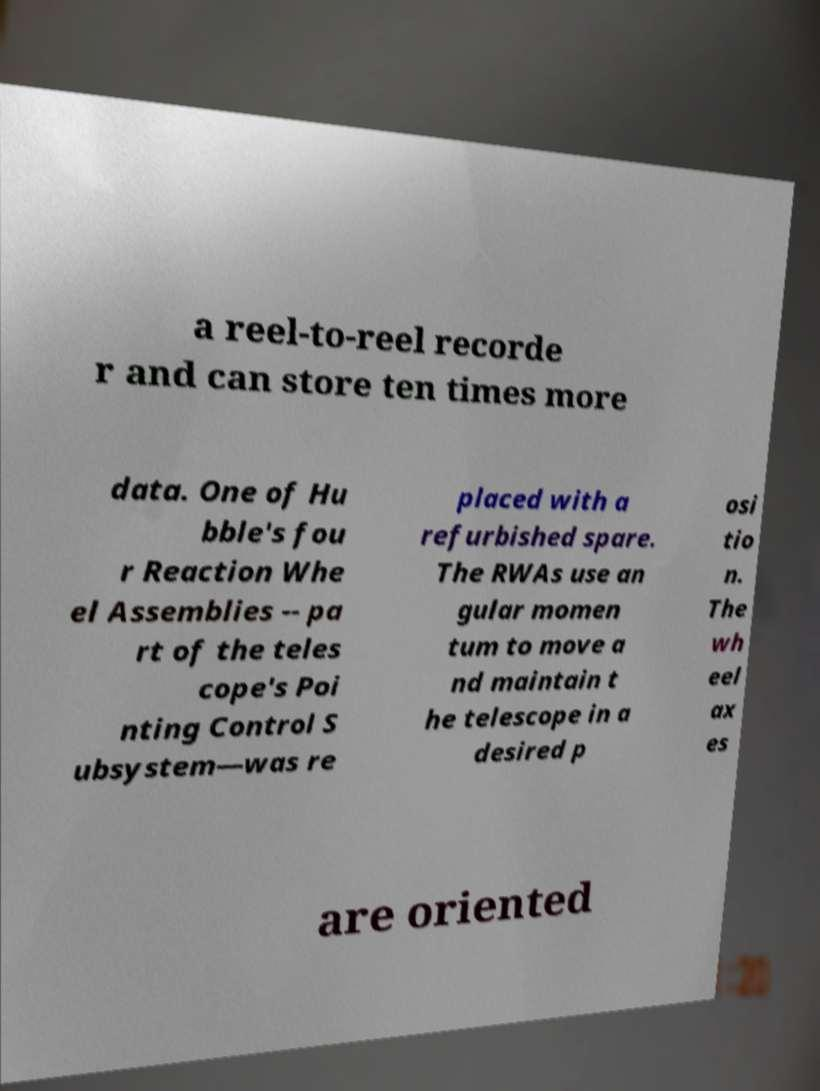For documentation purposes, I need the text within this image transcribed. Could you provide that? a reel-to-reel recorde r and can store ten times more data. One of Hu bble's fou r Reaction Whe el Assemblies -- pa rt of the teles cope's Poi nting Control S ubsystem—was re placed with a refurbished spare. The RWAs use an gular momen tum to move a nd maintain t he telescope in a desired p osi tio n. The wh eel ax es are oriented 